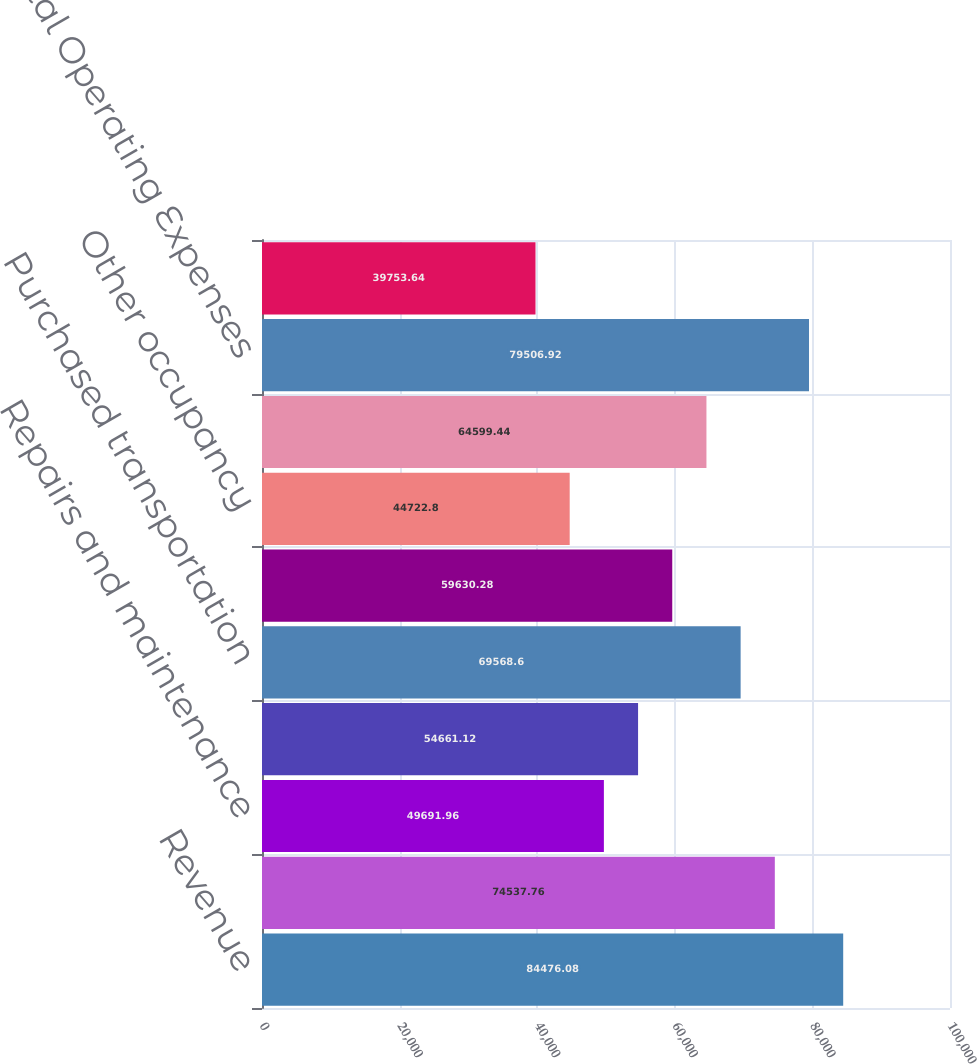<chart> <loc_0><loc_0><loc_500><loc_500><bar_chart><fcel>Revenue<fcel>Compensation and benefits<fcel>Repairs and maintenance<fcel>Depreciation and amortization<fcel>Purchased transportation<fcel>Fuel<fcel>Other occupancy<fcel>Other expenses<fcel>Total Operating Expenses<fcel>Operating Profit<nl><fcel>84476.1<fcel>74537.8<fcel>49692<fcel>54661.1<fcel>69568.6<fcel>59630.3<fcel>44722.8<fcel>64599.4<fcel>79506.9<fcel>39753.6<nl></chart> 